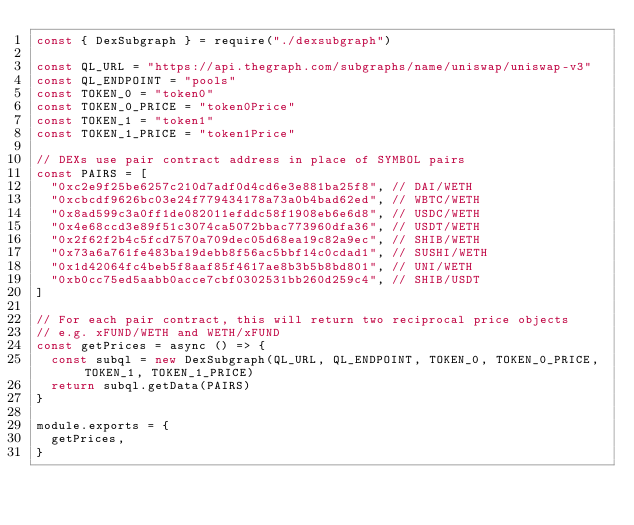Convert code to text. <code><loc_0><loc_0><loc_500><loc_500><_JavaScript_>const { DexSubgraph } = require("./dexsubgraph")

const QL_URL = "https://api.thegraph.com/subgraphs/name/uniswap/uniswap-v3"
const QL_ENDPOINT = "pools"
const TOKEN_0 = "token0"
const TOKEN_0_PRICE = "token0Price"
const TOKEN_1 = "token1"
const TOKEN_1_PRICE = "token1Price"

// DEXs use pair contract address in place of SYMBOL pairs
const PAIRS = [
  "0xc2e9f25be6257c210d7adf0d4cd6e3e881ba25f8", // DAI/WETH
  "0xcbcdf9626bc03e24f779434178a73a0b4bad62ed", // WBTC/WETH
  "0x8ad599c3a0ff1de082011efddc58f1908eb6e6d8", // USDC/WETH
  "0x4e68ccd3e89f51c3074ca5072bbac773960dfa36", // USDT/WETH
  "0x2f62f2b4c5fcd7570a709dec05d68ea19c82a9ec", // SHIB/WETH
  "0x73a6a761fe483ba19debb8f56ac5bbf14c0cdad1", // SUSHI/WETH
  "0x1d42064fc4beb5f8aaf85f4617ae8b3b5b8bd801", // UNI/WETH
  "0xb0cc75ed5aabb0acce7cbf0302531bb260d259c4", // SHIB/USDT
]

// For each pair contract, this will return two reciprocal price objects
// e.g. xFUND/WETH and WETH/xFUND
const getPrices = async () => {
  const subql = new DexSubgraph(QL_URL, QL_ENDPOINT, TOKEN_0, TOKEN_0_PRICE, TOKEN_1, TOKEN_1_PRICE)
  return subql.getData(PAIRS)
}

module.exports = {
  getPrices,
}
</code> 